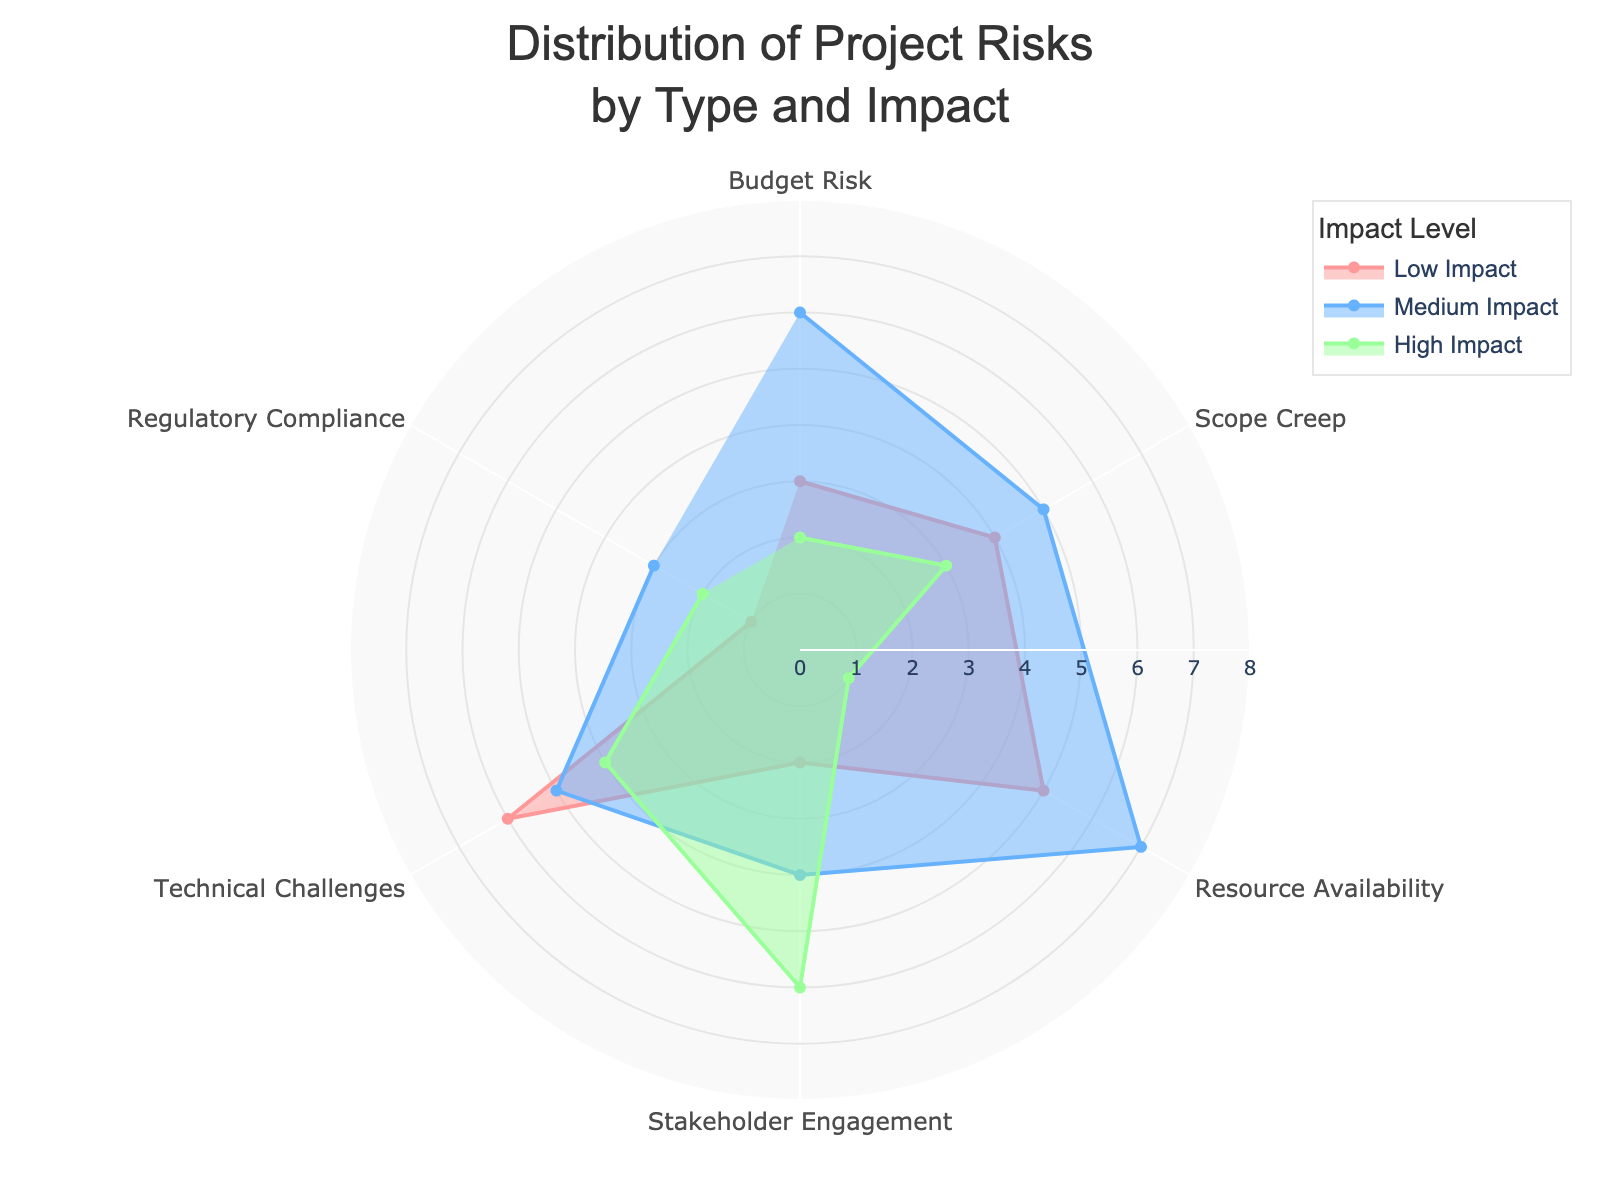What is the title of the radar chart? The title of the radar chart is located at the top and it indicates the main subject of the chart. From the given code, the title of the chart is 'Distribution of Project Risks by Type and Impact'.
Answer: Distribution of Project Risks by Type and Impact How many categories of project risks are displayed on the chart? To determine the number of categories, one needs to count the unique labels on the angular axis of the radar chart. The chart displays six categories: Budget Risk, Scope Creep, Resource Availability, Stakeholder Engagement, Technical Challenges, and Regulatory Compliance.
Answer: 6 Which category has the highest high-impact risk? To answer this, observe the 'High Impact' trace (often represented by one of the colored fills). The radius (r) values for 'High Impact' are plotted against each category. From the code, Stakeholder Engagement has the highest high-impact risk with a value of 6.
Answer: Stakeholder Engagement What is the sum of medium impact values across all categories? To find this, sum all the values under 'Medium Impact'. From the data: 6 (Budget Risk) + 5 (Scope Creep) + 7 (Resource Availability) + 4 (Stakeholder Engagement) + 5 (Technical Challenges) + 3 (Regulatory Compliance) which equals 30.
Answer: 30 Which category has equally distributed values for low, medium, and high impacts? To determine this, check where low, medium, and high impact values are equal. From the given data, no categories have equally distributed values for low, medium, and high impacts.
Answer: None Compare and state whether Budget Risk has a higher low impact or high impact value. To compare, refer to the values for Budget Risk under 'Low Impact' and 'High Impact'. Budget Risk has a 'Low Impact' value of 3 and a 'High Impact' value of 2. Therefore, the low impact value is higher.
Answer: Low Impact Which two categories have the highest combined medium and high impact values? To answer this, add the medium and high impact values for each category and compare. Calculations: Budget Risk: 6+2=8, Scope Creep: 5+3=8, Resource Availability: 7+1=8, Stakeholder Engagement: 4+6=10, Technical Challenges: 5+4=9, Regulatory Compliance: 3+2=5. Stakeholder Engagement (10) and Technical Challenges (9) have the highest combined values.
Answer: Stakeholder Engagement and Technical Challenges What is the average low impact value across all categories? To calculate the average, sum all low impact values and divide by the number of categories. Sum of low impacts: 3 (Budget Risk) + 4 (Scope Creep) + 5 (Resource Availability) + 2 (Stakeholder Engagement) + 6 (Technical Challenges) + 1 (Regulatory Compliance) = 21. Number of categories is 6. Therefore, average = 21/6 = 3.5.
Answer: 3.5 